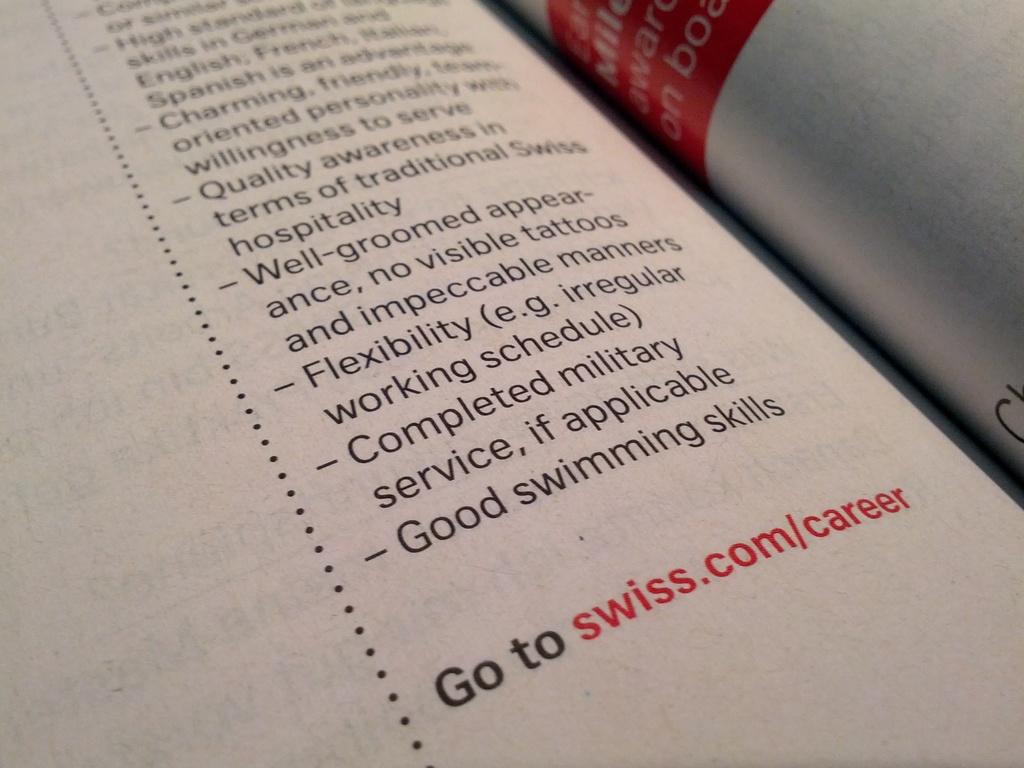What level swimming skills are required?
Keep it short and to the point. Good. What is the website?
Make the answer very short. Swiss.com/career. 